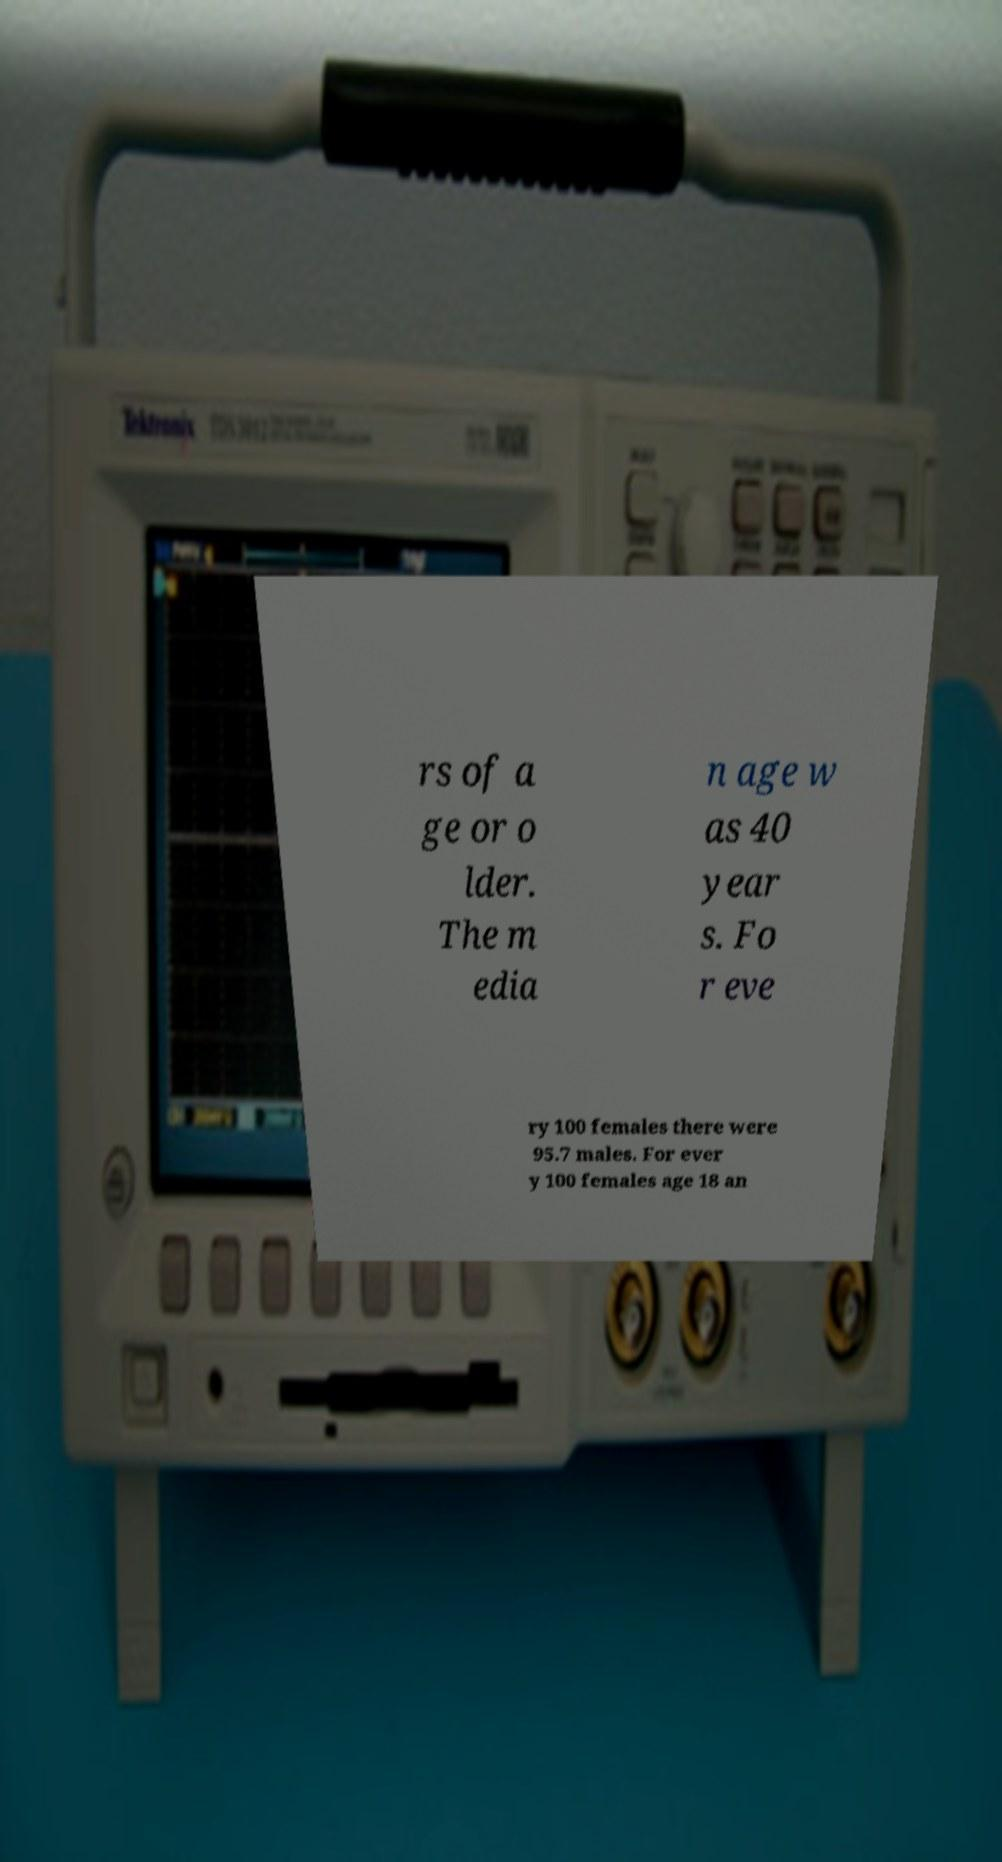Can you accurately transcribe the text from the provided image for me? rs of a ge or o lder. The m edia n age w as 40 year s. Fo r eve ry 100 females there were 95.7 males. For ever y 100 females age 18 an 